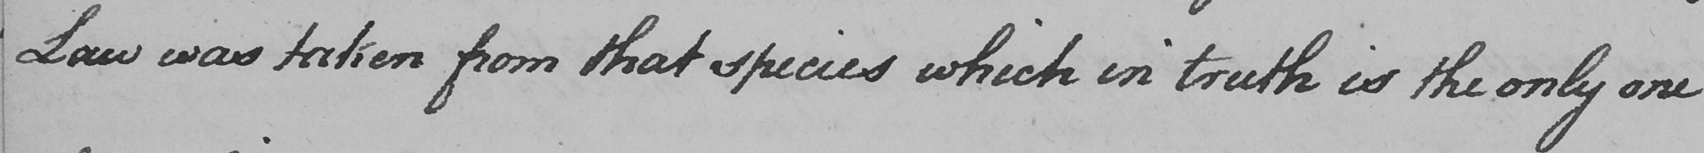What is written in this line of handwriting? Law was taken from that species which in truth is the only one 